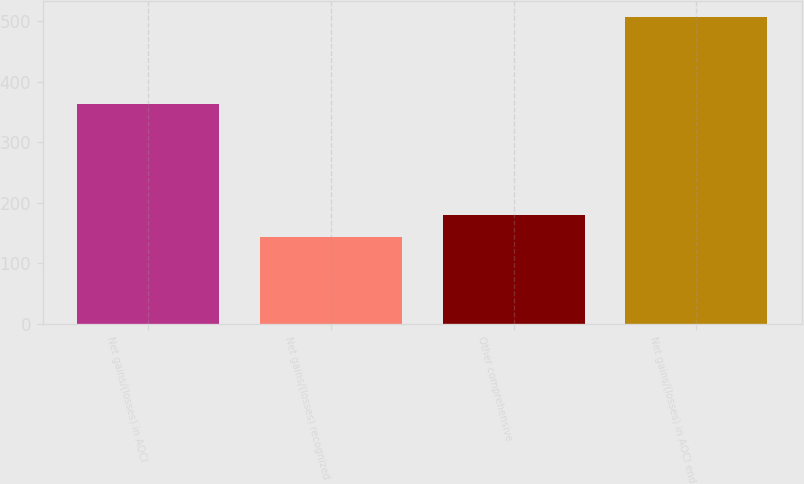Convert chart to OTSL. <chart><loc_0><loc_0><loc_500><loc_500><bar_chart><fcel>Net gains/(losses) in AOCI<fcel>Net gains/(losses) recognized<fcel>Other comprehensive<fcel>Net gains/(losses) in AOCI end<nl><fcel>362.7<fcel>143.7<fcel>180.14<fcel>508.1<nl></chart> 